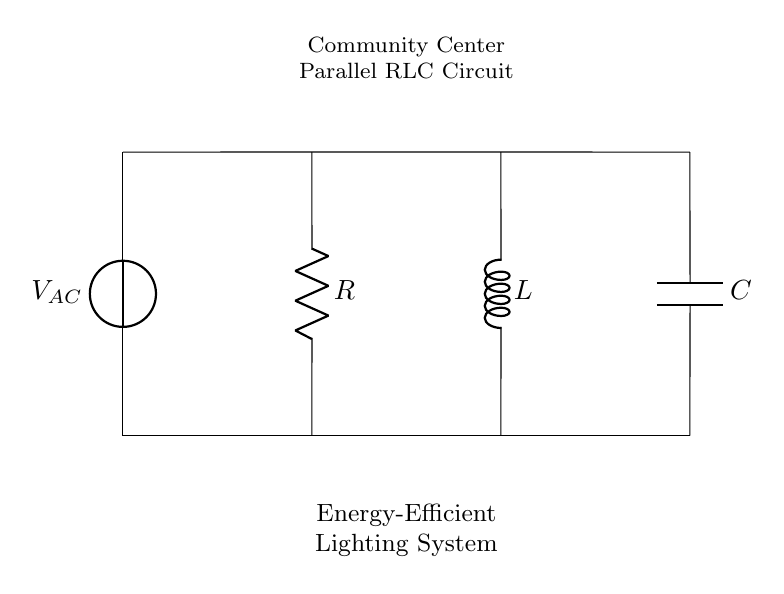What type of circuit is this? This is a parallel RLC circuit, which includes a resistor, inductor, and capacitor connected in parallel. The components are shown in parallel between the voltage source at the top and the ground at the bottom.
Answer: parallel RLC circuit What does the 'V' label represent? The 'V' label stands for the voltage source in the circuit, which is providing the alternating current, indicated as V sub AC. This element is crucial for powering the lighting system in the community center.
Answer: voltage source What components are used in the circuit? The circuit contains three main components: a resistor, an inductor, and a capacitor. These are standard elements in many electrical circuits for managing current and voltage effectively.
Answer: resistor, inductor, capacitor How many branches are in the circuit? Since the circuit has three components connected in parallel, there are three branches in the circuit. Each branch corresponds to one of the components, allowing for independent current flow.
Answer: three What role does the inductor play in this circuit? The inductor helps manage current fluctuations and can store energy in its magnetic field. In this circuit, it helps improve the stability of the lighting system when voltage changes occur.
Answer: manage current fluctuations What would happen if the resistance is increased? Increasing the resistance would reduce the current flowing through the resistor branch as per Ohm's law. This could affect the overall power consumed by the lighting system, potentially leading to lower brightness.
Answer: reduce current What is the purpose of the capacitor in this circuit? The capacitor is used to store and release electrical energy, helping to smooth out voltage fluctuations and improve power quality for the lighting system. Its role is critical for maintaining consistent light output.
Answer: store and release energy 